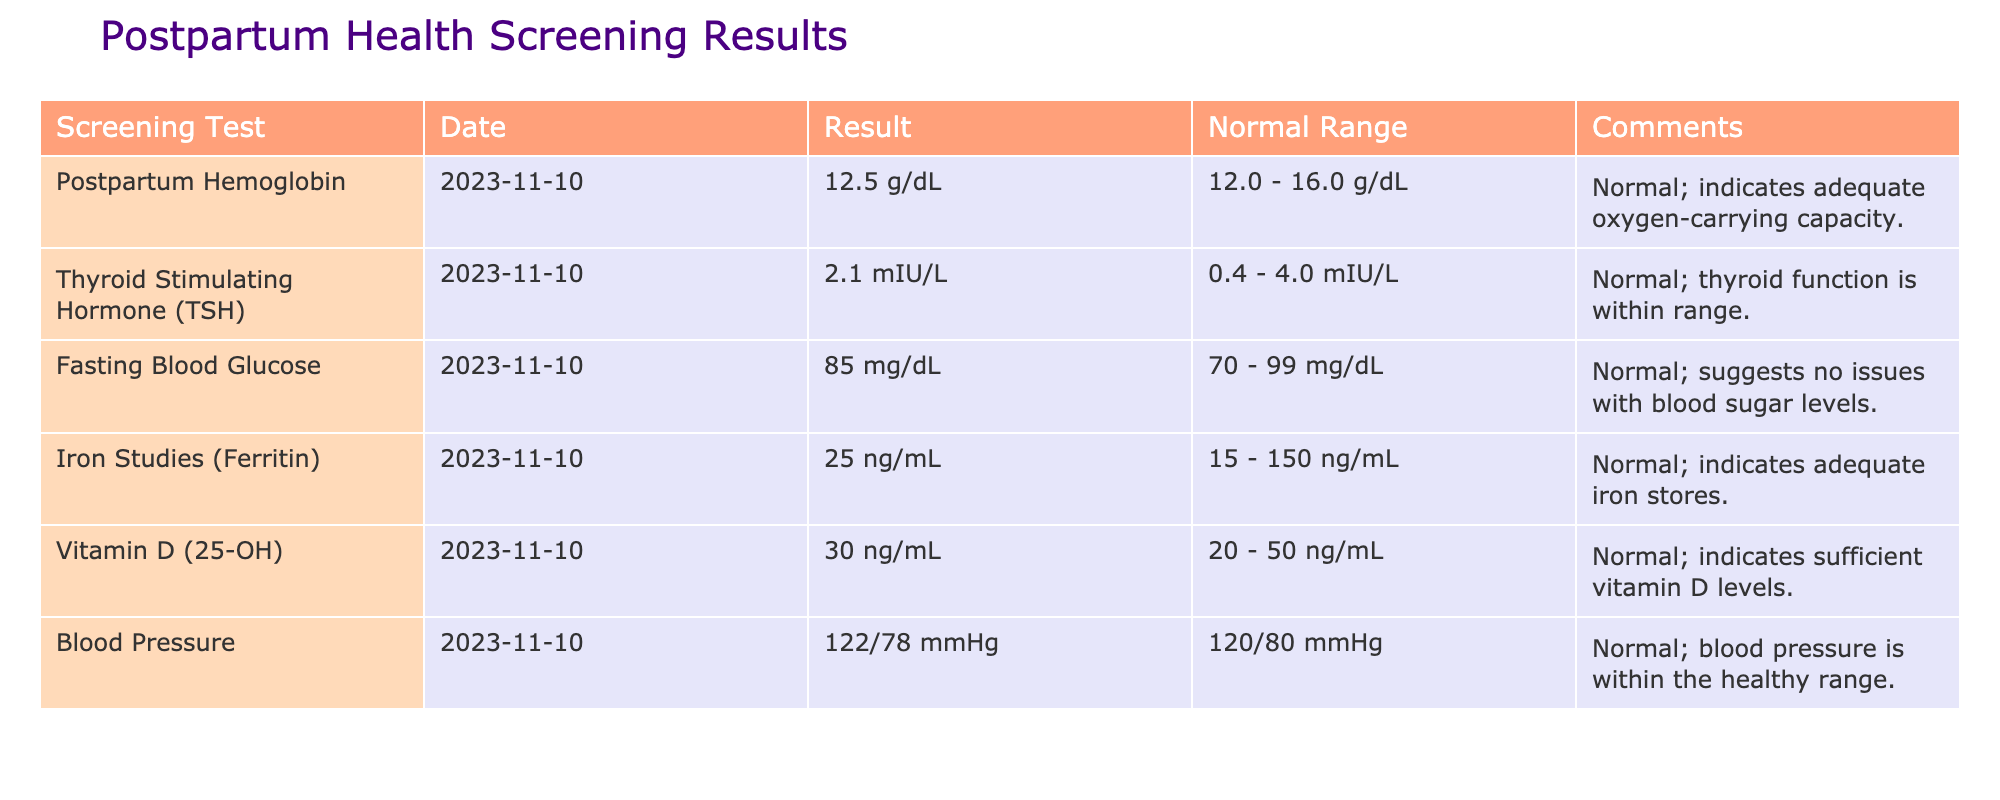What was the result for Postpartum Hemoglobin? The table indicates that the result for Postpartum Hemoglobin is 12.5 g/dL.
Answer: 12.5 g/dL Is the result for the Thyroid Stimulating Hormone (TSH) within the normal range? Yes, the TSH result is 2.1 mIU/L, which falls within the normal range of 0.4 - 4.0 mIU/L.
Answer: Yes What is the difference between the normal range and the result for Iron Studies (Ferritin)? The result for Iron Studies (Ferritin) is 25 ng/mL, and the normal range is 15 - 150 ng/mL. The difference between the result and the lower limit of the normal range is 25 - 15 = 10 ng/mL, and the difference with the upper limit is 150 - 25 = 125 ng/mL.
Answer: 10 ng/mL (lower), 125 ng/mL (upper) What is the average result of the vitamin D and fasting blood glucose tests? The result for Vitamin D is 30 ng/mL, and for Fasting Blood Glucose is 85 mg/dL. To find the average, convert Vitamin D to the same unit as blood glucose for context, then sum the results: (30 + 85) / 2 = 115 / 2 = 57.5.
Answer: 57.5 Is the Blood Pressure measurement considered normal? Yes, the Blood Pressure result is 122/78 mmHg, which aligns closely with the normal reading of 120/80 mmHg.
Answer: Yes 